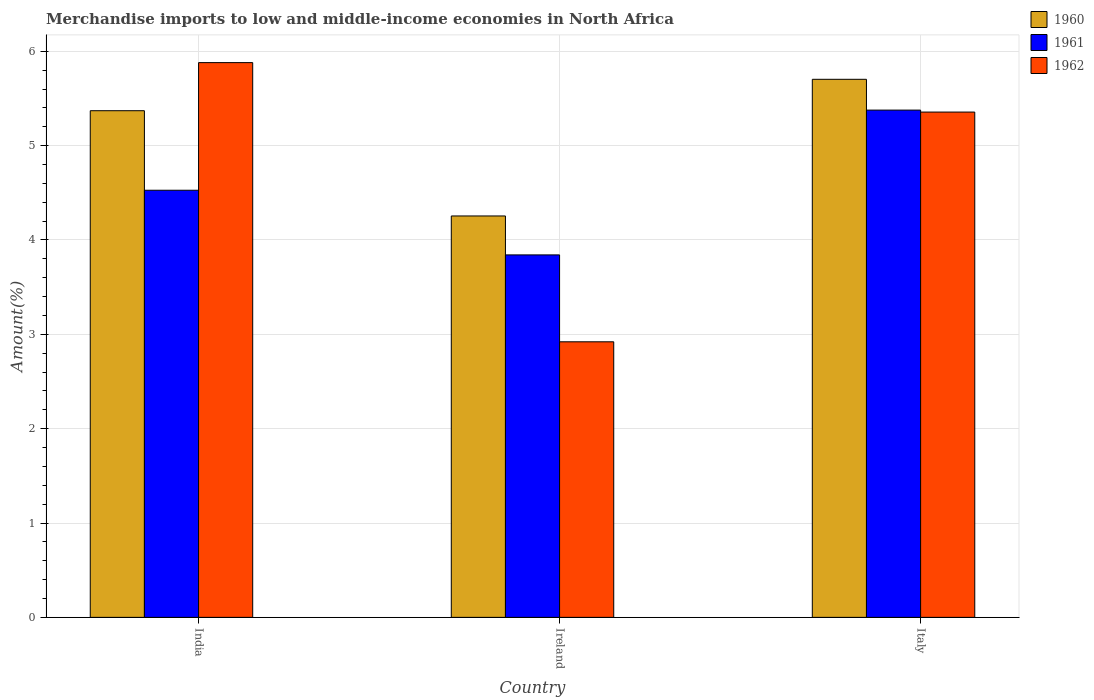How many groups of bars are there?
Provide a short and direct response. 3. Are the number of bars per tick equal to the number of legend labels?
Provide a short and direct response. Yes. Are the number of bars on each tick of the X-axis equal?
Provide a short and direct response. Yes. How many bars are there on the 1st tick from the left?
Provide a short and direct response. 3. How many bars are there on the 3rd tick from the right?
Provide a succinct answer. 3. What is the label of the 2nd group of bars from the left?
Offer a terse response. Ireland. What is the percentage of amount earned from merchandise imports in 1962 in India?
Make the answer very short. 5.88. Across all countries, what is the maximum percentage of amount earned from merchandise imports in 1962?
Your answer should be compact. 5.88. Across all countries, what is the minimum percentage of amount earned from merchandise imports in 1961?
Ensure brevity in your answer.  3.84. In which country was the percentage of amount earned from merchandise imports in 1961 minimum?
Give a very brief answer. Ireland. What is the total percentage of amount earned from merchandise imports in 1962 in the graph?
Your answer should be compact. 14.16. What is the difference between the percentage of amount earned from merchandise imports in 1960 in Ireland and that in Italy?
Your answer should be very brief. -1.45. What is the difference between the percentage of amount earned from merchandise imports in 1962 in India and the percentage of amount earned from merchandise imports in 1960 in Italy?
Give a very brief answer. 0.18. What is the average percentage of amount earned from merchandise imports in 1962 per country?
Your response must be concise. 4.72. What is the difference between the percentage of amount earned from merchandise imports of/in 1962 and percentage of amount earned from merchandise imports of/in 1960 in India?
Your response must be concise. 0.51. What is the ratio of the percentage of amount earned from merchandise imports in 1961 in India to that in Italy?
Provide a succinct answer. 0.84. What is the difference between the highest and the second highest percentage of amount earned from merchandise imports in 1961?
Give a very brief answer. -0.69. What is the difference between the highest and the lowest percentage of amount earned from merchandise imports in 1961?
Make the answer very short. 1.53. Is the sum of the percentage of amount earned from merchandise imports in 1960 in India and Ireland greater than the maximum percentage of amount earned from merchandise imports in 1961 across all countries?
Provide a short and direct response. Yes. What does the 3rd bar from the left in Italy represents?
Offer a terse response. 1962. Is it the case that in every country, the sum of the percentage of amount earned from merchandise imports in 1961 and percentage of amount earned from merchandise imports in 1962 is greater than the percentage of amount earned from merchandise imports in 1960?
Your answer should be compact. Yes. How many countries are there in the graph?
Keep it short and to the point. 3. What is the difference between two consecutive major ticks on the Y-axis?
Your answer should be very brief. 1. Are the values on the major ticks of Y-axis written in scientific E-notation?
Keep it short and to the point. No. Does the graph contain grids?
Offer a very short reply. Yes. What is the title of the graph?
Provide a succinct answer. Merchandise imports to low and middle-income economies in North Africa. What is the label or title of the X-axis?
Your answer should be very brief. Country. What is the label or title of the Y-axis?
Offer a very short reply. Amount(%). What is the Amount(%) in 1960 in India?
Ensure brevity in your answer.  5.37. What is the Amount(%) in 1961 in India?
Offer a terse response. 4.53. What is the Amount(%) of 1962 in India?
Your answer should be very brief. 5.88. What is the Amount(%) in 1960 in Ireland?
Give a very brief answer. 4.25. What is the Amount(%) of 1961 in Ireland?
Keep it short and to the point. 3.84. What is the Amount(%) of 1962 in Ireland?
Provide a succinct answer. 2.92. What is the Amount(%) in 1960 in Italy?
Offer a terse response. 5.7. What is the Amount(%) of 1961 in Italy?
Offer a very short reply. 5.38. What is the Amount(%) in 1962 in Italy?
Offer a terse response. 5.36. Across all countries, what is the maximum Amount(%) in 1960?
Your answer should be compact. 5.7. Across all countries, what is the maximum Amount(%) in 1961?
Provide a short and direct response. 5.38. Across all countries, what is the maximum Amount(%) of 1962?
Ensure brevity in your answer.  5.88. Across all countries, what is the minimum Amount(%) of 1960?
Your answer should be very brief. 4.25. Across all countries, what is the minimum Amount(%) in 1961?
Keep it short and to the point. 3.84. Across all countries, what is the minimum Amount(%) of 1962?
Offer a terse response. 2.92. What is the total Amount(%) in 1960 in the graph?
Your response must be concise. 15.33. What is the total Amount(%) of 1961 in the graph?
Provide a short and direct response. 13.75. What is the total Amount(%) in 1962 in the graph?
Offer a terse response. 14.16. What is the difference between the Amount(%) in 1960 in India and that in Ireland?
Give a very brief answer. 1.12. What is the difference between the Amount(%) of 1961 in India and that in Ireland?
Make the answer very short. 0.69. What is the difference between the Amount(%) of 1962 in India and that in Ireland?
Your response must be concise. 2.96. What is the difference between the Amount(%) in 1960 in India and that in Italy?
Your answer should be very brief. -0.33. What is the difference between the Amount(%) in 1961 in India and that in Italy?
Your answer should be very brief. -0.85. What is the difference between the Amount(%) in 1962 in India and that in Italy?
Ensure brevity in your answer.  0.52. What is the difference between the Amount(%) of 1960 in Ireland and that in Italy?
Offer a terse response. -1.45. What is the difference between the Amount(%) of 1961 in Ireland and that in Italy?
Provide a short and direct response. -1.53. What is the difference between the Amount(%) in 1962 in Ireland and that in Italy?
Offer a very short reply. -2.44. What is the difference between the Amount(%) in 1960 in India and the Amount(%) in 1961 in Ireland?
Offer a very short reply. 1.53. What is the difference between the Amount(%) of 1960 in India and the Amount(%) of 1962 in Ireland?
Provide a short and direct response. 2.45. What is the difference between the Amount(%) in 1961 in India and the Amount(%) in 1962 in Ireland?
Give a very brief answer. 1.61. What is the difference between the Amount(%) in 1960 in India and the Amount(%) in 1961 in Italy?
Keep it short and to the point. -0.01. What is the difference between the Amount(%) of 1960 in India and the Amount(%) of 1962 in Italy?
Offer a terse response. 0.01. What is the difference between the Amount(%) of 1961 in India and the Amount(%) of 1962 in Italy?
Offer a very short reply. -0.83. What is the difference between the Amount(%) in 1960 in Ireland and the Amount(%) in 1961 in Italy?
Offer a very short reply. -1.12. What is the difference between the Amount(%) in 1960 in Ireland and the Amount(%) in 1962 in Italy?
Provide a short and direct response. -1.1. What is the difference between the Amount(%) in 1961 in Ireland and the Amount(%) in 1962 in Italy?
Your response must be concise. -1.51. What is the average Amount(%) of 1960 per country?
Keep it short and to the point. 5.11. What is the average Amount(%) in 1961 per country?
Offer a terse response. 4.58. What is the average Amount(%) of 1962 per country?
Offer a very short reply. 4.72. What is the difference between the Amount(%) in 1960 and Amount(%) in 1961 in India?
Keep it short and to the point. 0.84. What is the difference between the Amount(%) of 1960 and Amount(%) of 1962 in India?
Your response must be concise. -0.51. What is the difference between the Amount(%) in 1961 and Amount(%) in 1962 in India?
Offer a very short reply. -1.35. What is the difference between the Amount(%) of 1960 and Amount(%) of 1961 in Ireland?
Give a very brief answer. 0.41. What is the difference between the Amount(%) of 1960 and Amount(%) of 1962 in Ireland?
Keep it short and to the point. 1.33. What is the difference between the Amount(%) in 1961 and Amount(%) in 1962 in Ireland?
Your answer should be very brief. 0.92. What is the difference between the Amount(%) of 1960 and Amount(%) of 1961 in Italy?
Provide a short and direct response. 0.33. What is the difference between the Amount(%) of 1960 and Amount(%) of 1962 in Italy?
Offer a terse response. 0.35. What is the difference between the Amount(%) of 1961 and Amount(%) of 1962 in Italy?
Your response must be concise. 0.02. What is the ratio of the Amount(%) in 1960 in India to that in Ireland?
Give a very brief answer. 1.26. What is the ratio of the Amount(%) in 1961 in India to that in Ireland?
Keep it short and to the point. 1.18. What is the ratio of the Amount(%) of 1962 in India to that in Ireland?
Ensure brevity in your answer.  2.01. What is the ratio of the Amount(%) in 1960 in India to that in Italy?
Provide a short and direct response. 0.94. What is the ratio of the Amount(%) of 1961 in India to that in Italy?
Keep it short and to the point. 0.84. What is the ratio of the Amount(%) of 1962 in India to that in Italy?
Your answer should be compact. 1.1. What is the ratio of the Amount(%) of 1960 in Ireland to that in Italy?
Your answer should be compact. 0.75. What is the ratio of the Amount(%) in 1961 in Ireland to that in Italy?
Ensure brevity in your answer.  0.71. What is the ratio of the Amount(%) of 1962 in Ireland to that in Italy?
Your answer should be compact. 0.55. What is the difference between the highest and the second highest Amount(%) in 1960?
Your answer should be compact. 0.33. What is the difference between the highest and the second highest Amount(%) in 1961?
Ensure brevity in your answer.  0.85. What is the difference between the highest and the second highest Amount(%) of 1962?
Provide a succinct answer. 0.52. What is the difference between the highest and the lowest Amount(%) in 1960?
Your answer should be compact. 1.45. What is the difference between the highest and the lowest Amount(%) in 1961?
Offer a very short reply. 1.53. What is the difference between the highest and the lowest Amount(%) of 1962?
Ensure brevity in your answer.  2.96. 